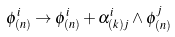Convert formula to latex. <formula><loc_0><loc_0><loc_500><loc_500>\phi ^ { i } _ { ( n ) } \rightarrow \phi ^ { i } _ { ( n ) } + \alpha ^ { i } _ { ( k ) j } \wedge \phi ^ { j } _ { ( n ) }</formula> 